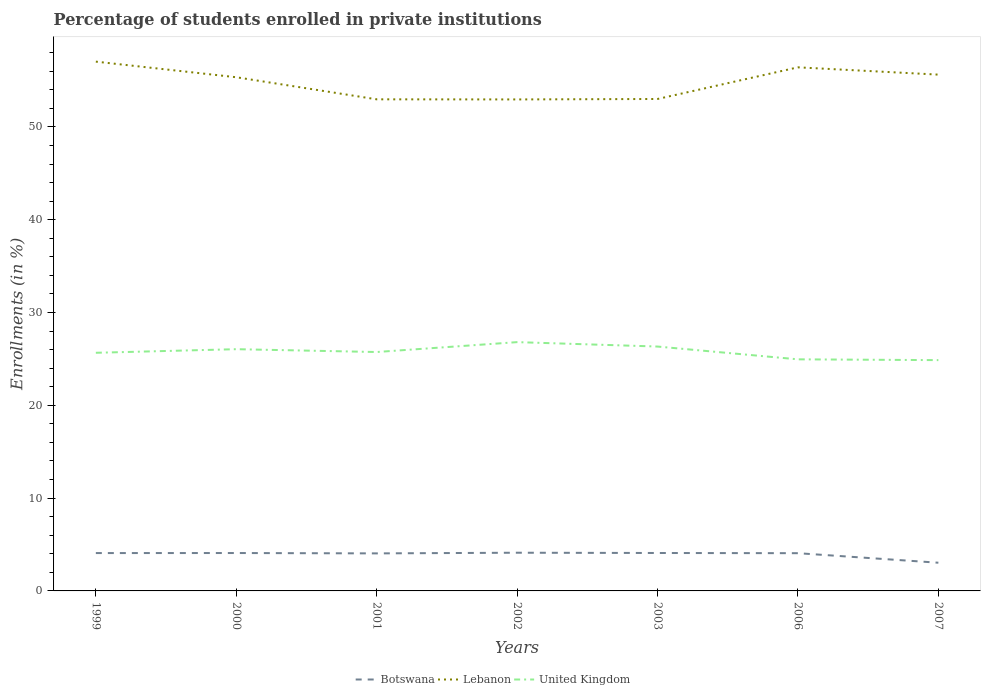Does the line corresponding to Botswana intersect with the line corresponding to Lebanon?
Provide a succinct answer. No. Across all years, what is the maximum percentage of trained teachers in Lebanon?
Provide a succinct answer. 52.96. In which year was the percentage of trained teachers in United Kingdom maximum?
Make the answer very short. 2007. What is the total percentage of trained teachers in Botswana in the graph?
Your answer should be very brief. -0.07. What is the difference between the highest and the second highest percentage of trained teachers in United Kingdom?
Ensure brevity in your answer.  1.94. Is the percentage of trained teachers in United Kingdom strictly greater than the percentage of trained teachers in Botswana over the years?
Your response must be concise. No. How many years are there in the graph?
Give a very brief answer. 7. What is the difference between two consecutive major ticks on the Y-axis?
Your answer should be compact. 10. Are the values on the major ticks of Y-axis written in scientific E-notation?
Your answer should be compact. No. Does the graph contain any zero values?
Provide a succinct answer. No. Does the graph contain grids?
Provide a short and direct response. No. Where does the legend appear in the graph?
Your answer should be very brief. Bottom center. How are the legend labels stacked?
Your answer should be compact. Horizontal. What is the title of the graph?
Keep it short and to the point. Percentage of students enrolled in private institutions. What is the label or title of the X-axis?
Provide a short and direct response. Years. What is the label or title of the Y-axis?
Your response must be concise. Enrollments (in %). What is the Enrollments (in %) of Botswana in 1999?
Ensure brevity in your answer.  4.08. What is the Enrollments (in %) of Lebanon in 1999?
Offer a very short reply. 57.03. What is the Enrollments (in %) of United Kingdom in 1999?
Keep it short and to the point. 25.66. What is the Enrollments (in %) in Botswana in 2000?
Keep it short and to the point. 4.08. What is the Enrollments (in %) of Lebanon in 2000?
Your response must be concise. 55.35. What is the Enrollments (in %) in United Kingdom in 2000?
Ensure brevity in your answer.  26.05. What is the Enrollments (in %) of Botswana in 2001?
Ensure brevity in your answer.  4.04. What is the Enrollments (in %) in Lebanon in 2001?
Your answer should be very brief. 52.97. What is the Enrollments (in %) of United Kingdom in 2001?
Provide a succinct answer. 25.74. What is the Enrollments (in %) in Botswana in 2002?
Make the answer very short. 4.12. What is the Enrollments (in %) of Lebanon in 2002?
Provide a short and direct response. 52.96. What is the Enrollments (in %) of United Kingdom in 2002?
Provide a short and direct response. 26.81. What is the Enrollments (in %) in Botswana in 2003?
Your answer should be very brief. 4.09. What is the Enrollments (in %) in Lebanon in 2003?
Ensure brevity in your answer.  53.01. What is the Enrollments (in %) of United Kingdom in 2003?
Offer a very short reply. 26.33. What is the Enrollments (in %) of Botswana in 2006?
Your response must be concise. 4.07. What is the Enrollments (in %) of Lebanon in 2006?
Provide a short and direct response. 56.42. What is the Enrollments (in %) in United Kingdom in 2006?
Provide a short and direct response. 24.95. What is the Enrollments (in %) of Botswana in 2007?
Make the answer very short. 3.04. What is the Enrollments (in %) in Lebanon in 2007?
Keep it short and to the point. 55.63. What is the Enrollments (in %) in United Kingdom in 2007?
Keep it short and to the point. 24.87. Across all years, what is the maximum Enrollments (in %) of Botswana?
Make the answer very short. 4.12. Across all years, what is the maximum Enrollments (in %) in Lebanon?
Your answer should be very brief. 57.03. Across all years, what is the maximum Enrollments (in %) in United Kingdom?
Provide a short and direct response. 26.81. Across all years, what is the minimum Enrollments (in %) of Botswana?
Ensure brevity in your answer.  3.04. Across all years, what is the minimum Enrollments (in %) of Lebanon?
Your answer should be very brief. 52.96. Across all years, what is the minimum Enrollments (in %) in United Kingdom?
Your response must be concise. 24.87. What is the total Enrollments (in %) of Botswana in the graph?
Offer a terse response. 27.51. What is the total Enrollments (in %) of Lebanon in the graph?
Your answer should be compact. 383.38. What is the total Enrollments (in %) in United Kingdom in the graph?
Your answer should be very brief. 180.42. What is the difference between the Enrollments (in %) in Botswana in 1999 and that in 2000?
Offer a very short reply. -0. What is the difference between the Enrollments (in %) in Lebanon in 1999 and that in 2000?
Keep it short and to the point. 1.68. What is the difference between the Enrollments (in %) in United Kingdom in 1999 and that in 2000?
Ensure brevity in your answer.  -0.39. What is the difference between the Enrollments (in %) of Botswana in 1999 and that in 2001?
Give a very brief answer. 0.03. What is the difference between the Enrollments (in %) of Lebanon in 1999 and that in 2001?
Your answer should be very brief. 4.06. What is the difference between the Enrollments (in %) of United Kingdom in 1999 and that in 2001?
Keep it short and to the point. -0.08. What is the difference between the Enrollments (in %) in Botswana in 1999 and that in 2002?
Ensure brevity in your answer.  -0.04. What is the difference between the Enrollments (in %) in Lebanon in 1999 and that in 2002?
Ensure brevity in your answer.  4.07. What is the difference between the Enrollments (in %) of United Kingdom in 1999 and that in 2002?
Ensure brevity in your answer.  -1.15. What is the difference between the Enrollments (in %) of Botswana in 1999 and that in 2003?
Provide a succinct answer. -0.01. What is the difference between the Enrollments (in %) in Lebanon in 1999 and that in 2003?
Offer a terse response. 4.03. What is the difference between the Enrollments (in %) of United Kingdom in 1999 and that in 2003?
Provide a short and direct response. -0.67. What is the difference between the Enrollments (in %) in Botswana in 1999 and that in 2006?
Keep it short and to the point. 0.01. What is the difference between the Enrollments (in %) of Lebanon in 1999 and that in 2006?
Your answer should be compact. 0.61. What is the difference between the Enrollments (in %) in United Kingdom in 1999 and that in 2006?
Give a very brief answer. 0.71. What is the difference between the Enrollments (in %) of Botswana in 1999 and that in 2007?
Make the answer very short. 1.04. What is the difference between the Enrollments (in %) of Lebanon in 1999 and that in 2007?
Offer a terse response. 1.4. What is the difference between the Enrollments (in %) in United Kingdom in 1999 and that in 2007?
Ensure brevity in your answer.  0.79. What is the difference between the Enrollments (in %) of Botswana in 2000 and that in 2001?
Ensure brevity in your answer.  0.04. What is the difference between the Enrollments (in %) of Lebanon in 2000 and that in 2001?
Keep it short and to the point. 2.38. What is the difference between the Enrollments (in %) of United Kingdom in 2000 and that in 2001?
Provide a succinct answer. 0.31. What is the difference between the Enrollments (in %) of Botswana in 2000 and that in 2002?
Give a very brief answer. -0.03. What is the difference between the Enrollments (in %) in Lebanon in 2000 and that in 2002?
Your answer should be compact. 2.39. What is the difference between the Enrollments (in %) in United Kingdom in 2000 and that in 2002?
Provide a short and direct response. -0.76. What is the difference between the Enrollments (in %) of Botswana in 2000 and that in 2003?
Keep it short and to the point. -0. What is the difference between the Enrollments (in %) of Lebanon in 2000 and that in 2003?
Make the answer very short. 2.34. What is the difference between the Enrollments (in %) of United Kingdom in 2000 and that in 2003?
Make the answer very short. -0.28. What is the difference between the Enrollments (in %) of Botswana in 2000 and that in 2006?
Offer a terse response. 0.02. What is the difference between the Enrollments (in %) of Lebanon in 2000 and that in 2006?
Your answer should be compact. -1.07. What is the difference between the Enrollments (in %) in United Kingdom in 2000 and that in 2006?
Your response must be concise. 1.09. What is the difference between the Enrollments (in %) of Botswana in 2000 and that in 2007?
Provide a short and direct response. 1.04. What is the difference between the Enrollments (in %) of Lebanon in 2000 and that in 2007?
Ensure brevity in your answer.  -0.28. What is the difference between the Enrollments (in %) of United Kingdom in 2000 and that in 2007?
Your answer should be compact. 1.18. What is the difference between the Enrollments (in %) in Botswana in 2001 and that in 2002?
Your answer should be very brief. -0.07. What is the difference between the Enrollments (in %) in Lebanon in 2001 and that in 2002?
Make the answer very short. 0.01. What is the difference between the Enrollments (in %) in United Kingdom in 2001 and that in 2002?
Offer a terse response. -1.07. What is the difference between the Enrollments (in %) of Botswana in 2001 and that in 2003?
Your answer should be compact. -0.04. What is the difference between the Enrollments (in %) in Lebanon in 2001 and that in 2003?
Provide a short and direct response. -0.04. What is the difference between the Enrollments (in %) of United Kingdom in 2001 and that in 2003?
Make the answer very short. -0.59. What is the difference between the Enrollments (in %) of Botswana in 2001 and that in 2006?
Your answer should be very brief. -0.02. What is the difference between the Enrollments (in %) in Lebanon in 2001 and that in 2006?
Keep it short and to the point. -3.45. What is the difference between the Enrollments (in %) of United Kingdom in 2001 and that in 2006?
Your response must be concise. 0.79. What is the difference between the Enrollments (in %) in Lebanon in 2001 and that in 2007?
Provide a succinct answer. -2.66. What is the difference between the Enrollments (in %) of United Kingdom in 2001 and that in 2007?
Offer a very short reply. 0.87. What is the difference between the Enrollments (in %) of Botswana in 2002 and that in 2003?
Provide a succinct answer. 0.03. What is the difference between the Enrollments (in %) of Lebanon in 2002 and that in 2003?
Provide a succinct answer. -0.05. What is the difference between the Enrollments (in %) in United Kingdom in 2002 and that in 2003?
Offer a very short reply. 0.48. What is the difference between the Enrollments (in %) in Botswana in 2002 and that in 2006?
Give a very brief answer. 0.05. What is the difference between the Enrollments (in %) in Lebanon in 2002 and that in 2006?
Your response must be concise. -3.46. What is the difference between the Enrollments (in %) of United Kingdom in 2002 and that in 2006?
Your answer should be compact. 1.85. What is the difference between the Enrollments (in %) in Botswana in 2002 and that in 2007?
Offer a terse response. 1.08. What is the difference between the Enrollments (in %) in Lebanon in 2002 and that in 2007?
Provide a succinct answer. -2.67. What is the difference between the Enrollments (in %) in United Kingdom in 2002 and that in 2007?
Give a very brief answer. 1.94. What is the difference between the Enrollments (in %) of Botswana in 2003 and that in 2006?
Your answer should be very brief. 0.02. What is the difference between the Enrollments (in %) in Lebanon in 2003 and that in 2006?
Ensure brevity in your answer.  -3.41. What is the difference between the Enrollments (in %) in United Kingdom in 2003 and that in 2006?
Provide a short and direct response. 1.38. What is the difference between the Enrollments (in %) in Botswana in 2003 and that in 2007?
Your response must be concise. 1.05. What is the difference between the Enrollments (in %) of Lebanon in 2003 and that in 2007?
Your answer should be compact. -2.62. What is the difference between the Enrollments (in %) in United Kingdom in 2003 and that in 2007?
Your answer should be very brief. 1.46. What is the difference between the Enrollments (in %) of Botswana in 2006 and that in 2007?
Make the answer very short. 1.03. What is the difference between the Enrollments (in %) in Lebanon in 2006 and that in 2007?
Offer a terse response. 0.79. What is the difference between the Enrollments (in %) in United Kingdom in 2006 and that in 2007?
Keep it short and to the point. 0.09. What is the difference between the Enrollments (in %) in Botswana in 1999 and the Enrollments (in %) in Lebanon in 2000?
Your answer should be compact. -51.27. What is the difference between the Enrollments (in %) in Botswana in 1999 and the Enrollments (in %) in United Kingdom in 2000?
Make the answer very short. -21.97. What is the difference between the Enrollments (in %) in Lebanon in 1999 and the Enrollments (in %) in United Kingdom in 2000?
Your response must be concise. 30.99. What is the difference between the Enrollments (in %) in Botswana in 1999 and the Enrollments (in %) in Lebanon in 2001?
Offer a terse response. -48.89. What is the difference between the Enrollments (in %) of Botswana in 1999 and the Enrollments (in %) of United Kingdom in 2001?
Keep it short and to the point. -21.66. What is the difference between the Enrollments (in %) in Lebanon in 1999 and the Enrollments (in %) in United Kingdom in 2001?
Ensure brevity in your answer.  31.29. What is the difference between the Enrollments (in %) in Botswana in 1999 and the Enrollments (in %) in Lebanon in 2002?
Provide a succinct answer. -48.88. What is the difference between the Enrollments (in %) of Botswana in 1999 and the Enrollments (in %) of United Kingdom in 2002?
Your answer should be very brief. -22.73. What is the difference between the Enrollments (in %) of Lebanon in 1999 and the Enrollments (in %) of United Kingdom in 2002?
Your answer should be very brief. 30.23. What is the difference between the Enrollments (in %) in Botswana in 1999 and the Enrollments (in %) in Lebanon in 2003?
Your answer should be very brief. -48.93. What is the difference between the Enrollments (in %) of Botswana in 1999 and the Enrollments (in %) of United Kingdom in 2003?
Your answer should be very brief. -22.25. What is the difference between the Enrollments (in %) of Lebanon in 1999 and the Enrollments (in %) of United Kingdom in 2003?
Ensure brevity in your answer.  30.7. What is the difference between the Enrollments (in %) in Botswana in 1999 and the Enrollments (in %) in Lebanon in 2006?
Provide a succinct answer. -52.34. What is the difference between the Enrollments (in %) of Botswana in 1999 and the Enrollments (in %) of United Kingdom in 2006?
Provide a short and direct response. -20.88. What is the difference between the Enrollments (in %) of Lebanon in 1999 and the Enrollments (in %) of United Kingdom in 2006?
Your response must be concise. 32.08. What is the difference between the Enrollments (in %) in Botswana in 1999 and the Enrollments (in %) in Lebanon in 2007?
Offer a terse response. -51.55. What is the difference between the Enrollments (in %) of Botswana in 1999 and the Enrollments (in %) of United Kingdom in 2007?
Keep it short and to the point. -20.79. What is the difference between the Enrollments (in %) in Lebanon in 1999 and the Enrollments (in %) in United Kingdom in 2007?
Offer a terse response. 32.17. What is the difference between the Enrollments (in %) in Botswana in 2000 and the Enrollments (in %) in Lebanon in 2001?
Provide a short and direct response. -48.89. What is the difference between the Enrollments (in %) of Botswana in 2000 and the Enrollments (in %) of United Kingdom in 2001?
Offer a very short reply. -21.66. What is the difference between the Enrollments (in %) of Lebanon in 2000 and the Enrollments (in %) of United Kingdom in 2001?
Give a very brief answer. 29.61. What is the difference between the Enrollments (in %) of Botswana in 2000 and the Enrollments (in %) of Lebanon in 2002?
Your answer should be very brief. -48.88. What is the difference between the Enrollments (in %) of Botswana in 2000 and the Enrollments (in %) of United Kingdom in 2002?
Give a very brief answer. -22.73. What is the difference between the Enrollments (in %) of Lebanon in 2000 and the Enrollments (in %) of United Kingdom in 2002?
Provide a succinct answer. 28.54. What is the difference between the Enrollments (in %) in Botswana in 2000 and the Enrollments (in %) in Lebanon in 2003?
Offer a very short reply. -48.93. What is the difference between the Enrollments (in %) of Botswana in 2000 and the Enrollments (in %) of United Kingdom in 2003?
Your response must be concise. -22.25. What is the difference between the Enrollments (in %) of Lebanon in 2000 and the Enrollments (in %) of United Kingdom in 2003?
Keep it short and to the point. 29.02. What is the difference between the Enrollments (in %) in Botswana in 2000 and the Enrollments (in %) in Lebanon in 2006?
Provide a succinct answer. -52.34. What is the difference between the Enrollments (in %) in Botswana in 2000 and the Enrollments (in %) in United Kingdom in 2006?
Your answer should be compact. -20.87. What is the difference between the Enrollments (in %) of Lebanon in 2000 and the Enrollments (in %) of United Kingdom in 2006?
Make the answer very short. 30.4. What is the difference between the Enrollments (in %) of Botswana in 2000 and the Enrollments (in %) of Lebanon in 2007?
Your response must be concise. -51.55. What is the difference between the Enrollments (in %) of Botswana in 2000 and the Enrollments (in %) of United Kingdom in 2007?
Your response must be concise. -20.79. What is the difference between the Enrollments (in %) of Lebanon in 2000 and the Enrollments (in %) of United Kingdom in 2007?
Make the answer very short. 30.48. What is the difference between the Enrollments (in %) in Botswana in 2001 and the Enrollments (in %) in Lebanon in 2002?
Make the answer very short. -48.92. What is the difference between the Enrollments (in %) of Botswana in 2001 and the Enrollments (in %) of United Kingdom in 2002?
Make the answer very short. -22.76. What is the difference between the Enrollments (in %) in Lebanon in 2001 and the Enrollments (in %) in United Kingdom in 2002?
Offer a terse response. 26.16. What is the difference between the Enrollments (in %) of Botswana in 2001 and the Enrollments (in %) of Lebanon in 2003?
Provide a short and direct response. -48.96. What is the difference between the Enrollments (in %) in Botswana in 2001 and the Enrollments (in %) in United Kingdom in 2003?
Offer a terse response. -22.29. What is the difference between the Enrollments (in %) in Lebanon in 2001 and the Enrollments (in %) in United Kingdom in 2003?
Give a very brief answer. 26.64. What is the difference between the Enrollments (in %) in Botswana in 2001 and the Enrollments (in %) in Lebanon in 2006?
Your response must be concise. -52.37. What is the difference between the Enrollments (in %) in Botswana in 2001 and the Enrollments (in %) in United Kingdom in 2006?
Make the answer very short. -20.91. What is the difference between the Enrollments (in %) in Lebanon in 2001 and the Enrollments (in %) in United Kingdom in 2006?
Offer a very short reply. 28.02. What is the difference between the Enrollments (in %) in Botswana in 2001 and the Enrollments (in %) in Lebanon in 2007?
Your answer should be compact. -51.59. What is the difference between the Enrollments (in %) in Botswana in 2001 and the Enrollments (in %) in United Kingdom in 2007?
Your answer should be compact. -20.82. What is the difference between the Enrollments (in %) of Lebanon in 2001 and the Enrollments (in %) of United Kingdom in 2007?
Keep it short and to the point. 28.1. What is the difference between the Enrollments (in %) in Botswana in 2002 and the Enrollments (in %) in Lebanon in 2003?
Provide a succinct answer. -48.89. What is the difference between the Enrollments (in %) of Botswana in 2002 and the Enrollments (in %) of United Kingdom in 2003?
Provide a succinct answer. -22.22. What is the difference between the Enrollments (in %) in Lebanon in 2002 and the Enrollments (in %) in United Kingdom in 2003?
Your response must be concise. 26.63. What is the difference between the Enrollments (in %) of Botswana in 2002 and the Enrollments (in %) of Lebanon in 2006?
Offer a terse response. -52.3. What is the difference between the Enrollments (in %) in Botswana in 2002 and the Enrollments (in %) in United Kingdom in 2006?
Your response must be concise. -20.84. What is the difference between the Enrollments (in %) of Lebanon in 2002 and the Enrollments (in %) of United Kingdom in 2006?
Give a very brief answer. 28.01. What is the difference between the Enrollments (in %) in Botswana in 2002 and the Enrollments (in %) in Lebanon in 2007?
Provide a short and direct response. -51.52. What is the difference between the Enrollments (in %) of Botswana in 2002 and the Enrollments (in %) of United Kingdom in 2007?
Your response must be concise. -20.75. What is the difference between the Enrollments (in %) of Lebanon in 2002 and the Enrollments (in %) of United Kingdom in 2007?
Make the answer very short. 28.09. What is the difference between the Enrollments (in %) of Botswana in 2003 and the Enrollments (in %) of Lebanon in 2006?
Provide a short and direct response. -52.33. What is the difference between the Enrollments (in %) of Botswana in 2003 and the Enrollments (in %) of United Kingdom in 2006?
Your answer should be very brief. -20.87. What is the difference between the Enrollments (in %) of Lebanon in 2003 and the Enrollments (in %) of United Kingdom in 2006?
Ensure brevity in your answer.  28.05. What is the difference between the Enrollments (in %) of Botswana in 2003 and the Enrollments (in %) of Lebanon in 2007?
Offer a very short reply. -51.55. What is the difference between the Enrollments (in %) in Botswana in 2003 and the Enrollments (in %) in United Kingdom in 2007?
Your answer should be very brief. -20.78. What is the difference between the Enrollments (in %) of Lebanon in 2003 and the Enrollments (in %) of United Kingdom in 2007?
Your response must be concise. 28.14. What is the difference between the Enrollments (in %) of Botswana in 2006 and the Enrollments (in %) of Lebanon in 2007?
Ensure brevity in your answer.  -51.57. What is the difference between the Enrollments (in %) of Botswana in 2006 and the Enrollments (in %) of United Kingdom in 2007?
Your answer should be compact. -20.8. What is the difference between the Enrollments (in %) in Lebanon in 2006 and the Enrollments (in %) in United Kingdom in 2007?
Ensure brevity in your answer.  31.55. What is the average Enrollments (in %) in Botswana per year?
Offer a very short reply. 3.93. What is the average Enrollments (in %) in Lebanon per year?
Provide a short and direct response. 54.77. What is the average Enrollments (in %) of United Kingdom per year?
Offer a very short reply. 25.77. In the year 1999, what is the difference between the Enrollments (in %) in Botswana and Enrollments (in %) in Lebanon?
Offer a terse response. -52.95. In the year 1999, what is the difference between the Enrollments (in %) in Botswana and Enrollments (in %) in United Kingdom?
Provide a short and direct response. -21.58. In the year 1999, what is the difference between the Enrollments (in %) in Lebanon and Enrollments (in %) in United Kingdom?
Your response must be concise. 31.37. In the year 2000, what is the difference between the Enrollments (in %) in Botswana and Enrollments (in %) in Lebanon?
Your response must be concise. -51.27. In the year 2000, what is the difference between the Enrollments (in %) of Botswana and Enrollments (in %) of United Kingdom?
Keep it short and to the point. -21.96. In the year 2000, what is the difference between the Enrollments (in %) in Lebanon and Enrollments (in %) in United Kingdom?
Provide a short and direct response. 29.3. In the year 2001, what is the difference between the Enrollments (in %) in Botswana and Enrollments (in %) in Lebanon?
Your answer should be very brief. -48.93. In the year 2001, what is the difference between the Enrollments (in %) of Botswana and Enrollments (in %) of United Kingdom?
Your answer should be compact. -21.7. In the year 2001, what is the difference between the Enrollments (in %) in Lebanon and Enrollments (in %) in United Kingdom?
Offer a very short reply. 27.23. In the year 2002, what is the difference between the Enrollments (in %) in Botswana and Enrollments (in %) in Lebanon?
Make the answer very short. -48.84. In the year 2002, what is the difference between the Enrollments (in %) in Botswana and Enrollments (in %) in United Kingdom?
Make the answer very short. -22.69. In the year 2002, what is the difference between the Enrollments (in %) in Lebanon and Enrollments (in %) in United Kingdom?
Your response must be concise. 26.15. In the year 2003, what is the difference between the Enrollments (in %) in Botswana and Enrollments (in %) in Lebanon?
Your answer should be very brief. -48.92. In the year 2003, what is the difference between the Enrollments (in %) of Botswana and Enrollments (in %) of United Kingdom?
Offer a very short reply. -22.25. In the year 2003, what is the difference between the Enrollments (in %) of Lebanon and Enrollments (in %) of United Kingdom?
Give a very brief answer. 26.68. In the year 2006, what is the difference between the Enrollments (in %) of Botswana and Enrollments (in %) of Lebanon?
Offer a terse response. -52.35. In the year 2006, what is the difference between the Enrollments (in %) of Botswana and Enrollments (in %) of United Kingdom?
Keep it short and to the point. -20.89. In the year 2006, what is the difference between the Enrollments (in %) in Lebanon and Enrollments (in %) in United Kingdom?
Provide a short and direct response. 31.46. In the year 2007, what is the difference between the Enrollments (in %) in Botswana and Enrollments (in %) in Lebanon?
Keep it short and to the point. -52.6. In the year 2007, what is the difference between the Enrollments (in %) of Botswana and Enrollments (in %) of United Kingdom?
Your response must be concise. -21.83. In the year 2007, what is the difference between the Enrollments (in %) in Lebanon and Enrollments (in %) in United Kingdom?
Provide a succinct answer. 30.77. What is the ratio of the Enrollments (in %) of Botswana in 1999 to that in 2000?
Ensure brevity in your answer.  1. What is the ratio of the Enrollments (in %) in Lebanon in 1999 to that in 2000?
Provide a short and direct response. 1.03. What is the ratio of the Enrollments (in %) in United Kingdom in 1999 to that in 2000?
Provide a short and direct response. 0.99. What is the ratio of the Enrollments (in %) in Botswana in 1999 to that in 2001?
Keep it short and to the point. 1.01. What is the ratio of the Enrollments (in %) in Lebanon in 1999 to that in 2001?
Ensure brevity in your answer.  1.08. What is the ratio of the Enrollments (in %) of United Kingdom in 1999 to that in 2002?
Your response must be concise. 0.96. What is the ratio of the Enrollments (in %) in Botswana in 1999 to that in 2003?
Give a very brief answer. 1. What is the ratio of the Enrollments (in %) in Lebanon in 1999 to that in 2003?
Make the answer very short. 1.08. What is the ratio of the Enrollments (in %) in United Kingdom in 1999 to that in 2003?
Your response must be concise. 0.97. What is the ratio of the Enrollments (in %) of Lebanon in 1999 to that in 2006?
Offer a terse response. 1.01. What is the ratio of the Enrollments (in %) in United Kingdom in 1999 to that in 2006?
Provide a short and direct response. 1.03. What is the ratio of the Enrollments (in %) of Botswana in 1999 to that in 2007?
Offer a terse response. 1.34. What is the ratio of the Enrollments (in %) of Lebanon in 1999 to that in 2007?
Your answer should be compact. 1.03. What is the ratio of the Enrollments (in %) in United Kingdom in 1999 to that in 2007?
Ensure brevity in your answer.  1.03. What is the ratio of the Enrollments (in %) in Botswana in 2000 to that in 2001?
Provide a short and direct response. 1.01. What is the ratio of the Enrollments (in %) in Lebanon in 2000 to that in 2001?
Ensure brevity in your answer.  1.04. What is the ratio of the Enrollments (in %) in United Kingdom in 2000 to that in 2001?
Make the answer very short. 1.01. What is the ratio of the Enrollments (in %) of Lebanon in 2000 to that in 2002?
Your response must be concise. 1.05. What is the ratio of the Enrollments (in %) of United Kingdom in 2000 to that in 2002?
Your response must be concise. 0.97. What is the ratio of the Enrollments (in %) of Lebanon in 2000 to that in 2003?
Your answer should be compact. 1.04. What is the ratio of the Enrollments (in %) of United Kingdom in 2000 to that in 2003?
Ensure brevity in your answer.  0.99. What is the ratio of the Enrollments (in %) in Botswana in 2000 to that in 2006?
Your answer should be very brief. 1. What is the ratio of the Enrollments (in %) in Lebanon in 2000 to that in 2006?
Provide a short and direct response. 0.98. What is the ratio of the Enrollments (in %) in United Kingdom in 2000 to that in 2006?
Your response must be concise. 1.04. What is the ratio of the Enrollments (in %) in Botswana in 2000 to that in 2007?
Give a very brief answer. 1.34. What is the ratio of the Enrollments (in %) in United Kingdom in 2000 to that in 2007?
Ensure brevity in your answer.  1.05. What is the ratio of the Enrollments (in %) of Botswana in 2001 to that in 2002?
Your answer should be compact. 0.98. What is the ratio of the Enrollments (in %) in United Kingdom in 2001 to that in 2002?
Offer a terse response. 0.96. What is the ratio of the Enrollments (in %) in United Kingdom in 2001 to that in 2003?
Ensure brevity in your answer.  0.98. What is the ratio of the Enrollments (in %) of Lebanon in 2001 to that in 2006?
Your answer should be very brief. 0.94. What is the ratio of the Enrollments (in %) in United Kingdom in 2001 to that in 2006?
Make the answer very short. 1.03. What is the ratio of the Enrollments (in %) in Botswana in 2001 to that in 2007?
Your answer should be very brief. 1.33. What is the ratio of the Enrollments (in %) of Lebanon in 2001 to that in 2007?
Offer a very short reply. 0.95. What is the ratio of the Enrollments (in %) of United Kingdom in 2001 to that in 2007?
Offer a terse response. 1.04. What is the ratio of the Enrollments (in %) of United Kingdom in 2002 to that in 2003?
Keep it short and to the point. 1.02. What is the ratio of the Enrollments (in %) in Botswana in 2002 to that in 2006?
Your response must be concise. 1.01. What is the ratio of the Enrollments (in %) of Lebanon in 2002 to that in 2006?
Your answer should be very brief. 0.94. What is the ratio of the Enrollments (in %) of United Kingdom in 2002 to that in 2006?
Provide a short and direct response. 1.07. What is the ratio of the Enrollments (in %) of Botswana in 2002 to that in 2007?
Provide a short and direct response. 1.35. What is the ratio of the Enrollments (in %) in United Kingdom in 2002 to that in 2007?
Keep it short and to the point. 1.08. What is the ratio of the Enrollments (in %) in Botswana in 2003 to that in 2006?
Your answer should be very brief. 1.01. What is the ratio of the Enrollments (in %) of Lebanon in 2003 to that in 2006?
Provide a short and direct response. 0.94. What is the ratio of the Enrollments (in %) in United Kingdom in 2003 to that in 2006?
Your answer should be compact. 1.06. What is the ratio of the Enrollments (in %) in Botswana in 2003 to that in 2007?
Ensure brevity in your answer.  1.35. What is the ratio of the Enrollments (in %) in Lebanon in 2003 to that in 2007?
Your answer should be compact. 0.95. What is the ratio of the Enrollments (in %) of United Kingdom in 2003 to that in 2007?
Your answer should be very brief. 1.06. What is the ratio of the Enrollments (in %) in Botswana in 2006 to that in 2007?
Provide a succinct answer. 1.34. What is the ratio of the Enrollments (in %) in Lebanon in 2006 to that in 2007?
Offer a terse response. 1.01. What is the ratio of the Enrollments (in %) of United Kingdom in 2006 to that in 2007?
Offer a very short reply. 1. What is the difference between the highest and the second highest Enrollments (in %) of Botswana?
Offer a terse response. 0.03. What is the difference between the highest and the second highest Enrollments (in %) of Lebanon?
Provide a succinct answer. 0.61. What is the difference between the highest and the second highest Enrollments (in %) in United Kingdom?
Offer a very short reply. 0.48. What is the difference between the highest and the lowest Enrollments (in %) in Botswana?
Give a very brief answer. 1.08. What is the difference between the highest and the lowest Enrollments (in %) in Lebanon?
Keep it short and to the point. 4.07. What is the difference between the highest and the lowest Enrollments (in %) in United Kingdom?
Make the answer very short. 1.94. 